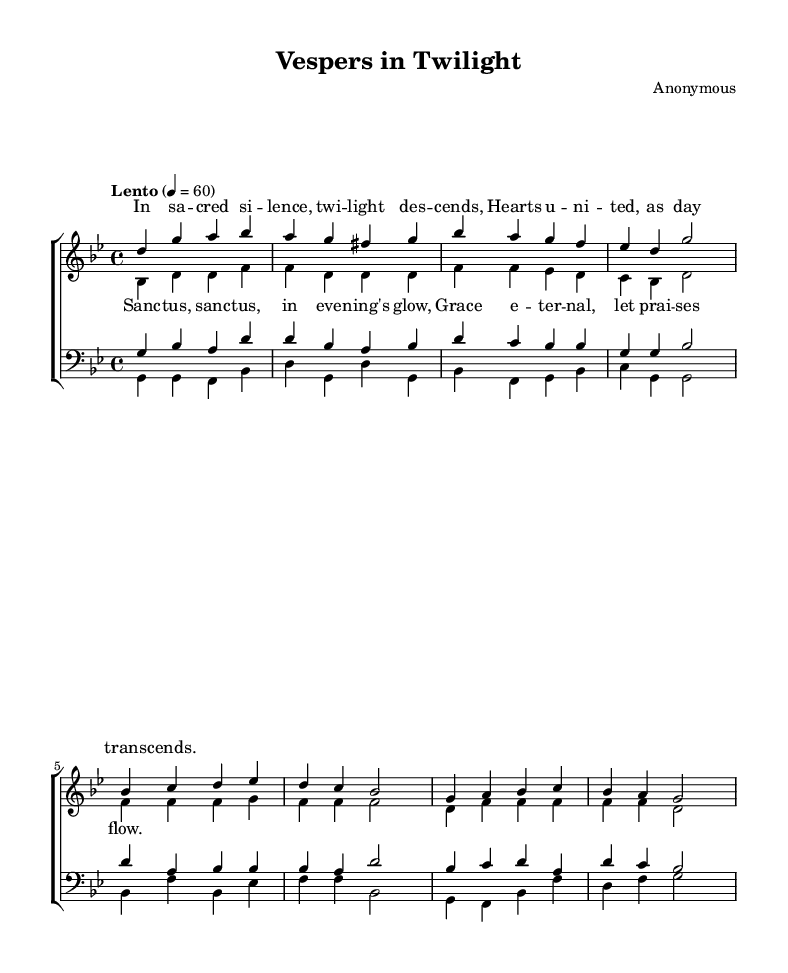What is the key signature of this music? The key signature is G minor, which has two flats (B♭ and E♭). This is indicated at the beginning of the staff where the key signature is placed.
Answer: G minor What is the time signature of this music? The time signature is 4/4, which means there are four beats in each measure and a quarter note gets one beat. This is indicated at the beginning of the score next to the key signature.
Answer: 4/4 What is the tempo marking for this piece? The tempo marking is "Lento," which indicates a slow pace. This is explicitly stated at the beginning of the score alongside the metronome marking "4 = 60."
Answer: Lento How many staves are used in the choir score? There are two main staves indicated, one for women (sopranos and altos) and one for men (tenors and basses). This can be seen at the top of the score where the staves are grouped together.
Answer: Two What type of musical setting is this piece categorized as? The piece is categorized as a choral setting, specifically religious choral music, based on its structure of vocal parts and the sacred nature of the text and title.
Answer: Choral What do the lyrics in the chorus emphasize? The lyrics in the chorus emphasize serenity and reverence, referencing "Sanc - tus, sanc - tus, in eve - ning's glow," which expresses a sense of sacredness typical of religious music. This can be understood by analyzing the text's content and emotional context.
Answer: Serenity How are the individual vocal parts structured in the score? The individual vocal parts are structured in a SATB format: Soprano, Alto, Tenor, and Bass, which is a common arrangement for choral music. Each part has its own designated section in the staff.
Answer: SATB 